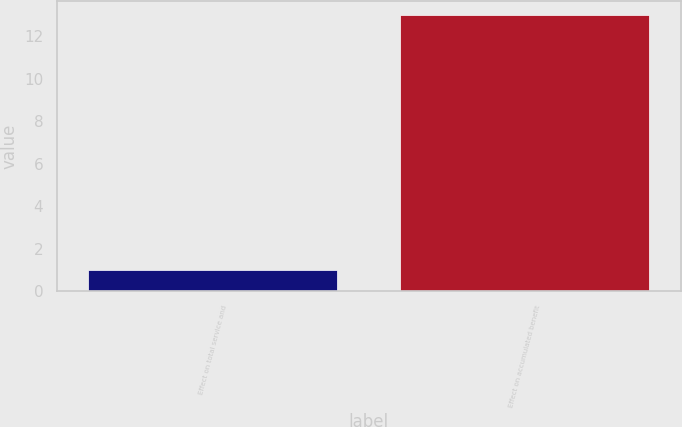<chart> <loc_0><loc_0><loc_500><loc_500><bar_chart><fcel>Effect on total service and<fcel>Effect on accumulated benefit<nl><fcel>1<fcel>13<nl></chart> 